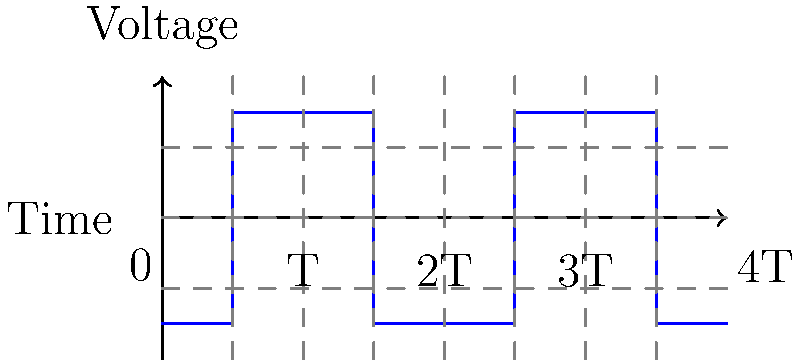In the oscilloscope display shown above, what type of waveform is represented, and what is its period in terms of T? To identify the waveform and determine its period, let's follow these steps:

1. Waveform identification:
   - The signal alternates between two fixed voltage levels.
   - The transitions between these levels are vertical, indicating instantaneous changes.
   - The signal remains at each level for equal durations.
   These characteristics are typical of a square wave.

2. Period determination:
   - The period of a waveform is the time it takes to complete one full cycle.
   - In this display, we can see that the waveform repeats its pattern every 2T units.
   - The signal starts at a low level, switches to a high level after T units, and then returns to the low level after another T units.
   - This complete cycle takes 2T units of time.

Therefore, the waveform is a square wave with a period of 2T.
Answer: Square wave with period 2T 